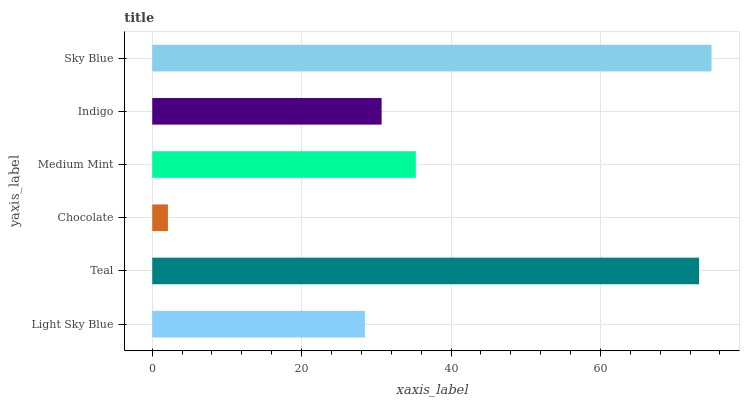Is Chocolate the minimum?
Answer yes or no. Yes. Is Sky Blue the maximum?
Answer yes or no. Yes. Is Teal the minimum?
Answer yes or no. No. Is Teal the maximum?
Answer yes or no. No. Is Teal greater than Light Sky Blue?
Answer yes or no. Yes. Is Light Sky Blue less than Teal?
Answer yes or no. Yes. Is Light Sky Blue greater than Teal?
Answer yes or no. No. Is Teal less than Light Sky Blue?
Answer yes or no. No. Is Medium Mint the high median?
Answer yes or no. Yes. Is Indigo the low median?
Answer yes or no. Yes. Is Indigo the high median?
Answer yes or no. No. Is Chocolate the low median?
Answer yes or no. No. 